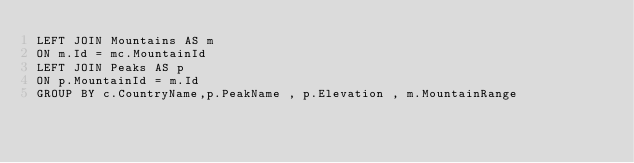Convert code to text. <code><loc_0><loc_0><loc_500><loc_500><_SQL_>LEFT JOIN Mountains AS m
ON m.Id = mc.MountainId
LEFT JOIN Peaks AS p
ON p.MountainId = m.Id 
GROUP BY c.CountryName,p.PeakName , p.Elevation , m.MountainRange
</code> 